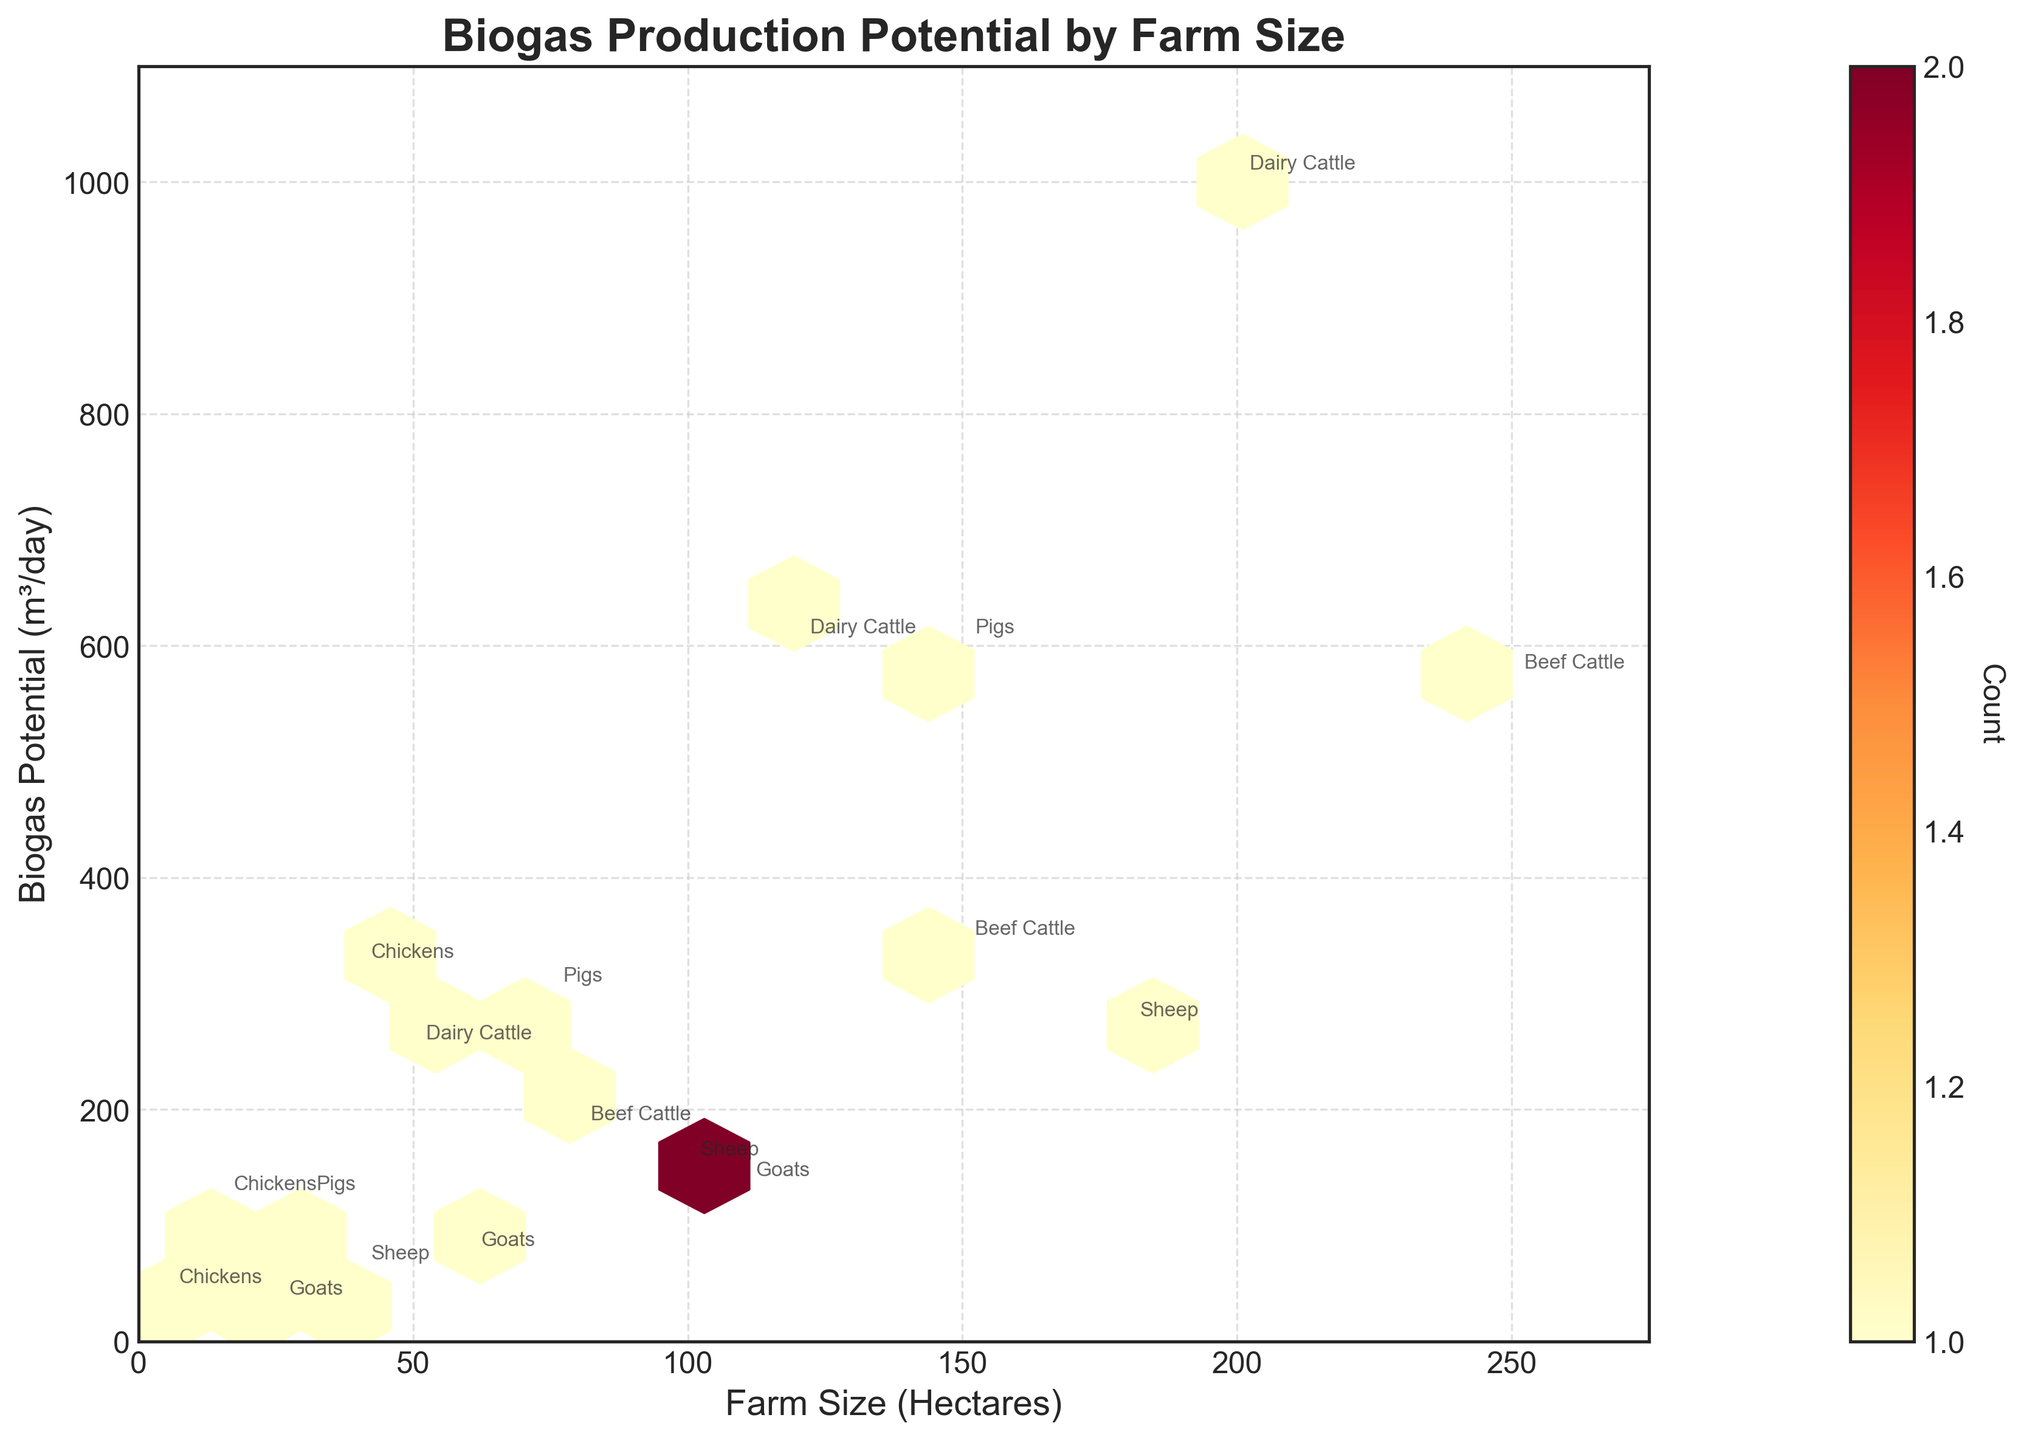How many animal types are annotated in the plot? The annotations on the plot mention different livestock species namely Dairy Cattle, Beef Cattle, Pigs, Chickens, Sheep, and Goats.
Answer: 6 What does the color intensity in the hexagons represent? The color intensity in the hexagons represents the count of data points within each bin, meaning darker colors correspond to higher counts.
Answer: Count of data points What is the general relationship between farm size and biogas potential indicated by the plot? The plot suggests a positive correlation where larger farm sizes tend to have higher biogas production potential. This is evident because the annotations for larger farm sizes are aligned with higher biogas potential values.
Answer: Positive correlation Compare the biogas potential of Dairy Cattle farms with Beef Cattle farms of similar sizes. Dairy Cattle farms tend to have higher biogas potential compared to Beef Cattle farms of similar sizes. For example, a 200-hectare Dairy Cattle farm produces 1000 m³/day of biogas, whereas a 250-hectare Beef Cattle farm produces only 570 m³/day.
Answer: Dairy Cattle farms have higher biogas potential Which farm size for Pigs has the highest biogas potential? Among the pig farms, the highest biogas potential corresponds to the farm size of 150 hectares, producing 600 m³/day of biogas.
Answer: 150 hectares How does the biogas potential of Chicken farms compare to that of Sheep farms? Chicken farms generally have higher biogas potential compared to Sheep farms. For instance, a 40-hectare chicken farm produces 320 m³/day, while a 40-hectare sheep farm produces only 60 m³/day.
Answer: Chicken farms have higher biogas potential Based on the plot, which animal type seems to have the least biogas potential for a given farm size? Goats seem to have the least biogas potential, as the annotations show lower biogas production values for various farm sizes compared to other animal types.
Answer: Goats What are the ranges of farm sizes and biogas potential values shown in the plot? The farm sizes range from 5 to 250 hectares. The biogas potential values range from 30 to 1000 m³/day.
Answer: Farm sizes: 5 to 250 hectares, Biogas potential: 30 to 1000 m³/day Which data point is a notable outlier in terms of biogas potential, considering similar farm sizes? The 200-hectare Dairy Cattle farm producing 1000 m³/day of biogas appears as an outlier considering similar farm sizes. Most other farms have lower biogas production for similar or even larger sizes.
Answer: 200-hectare Dairy Cattle 